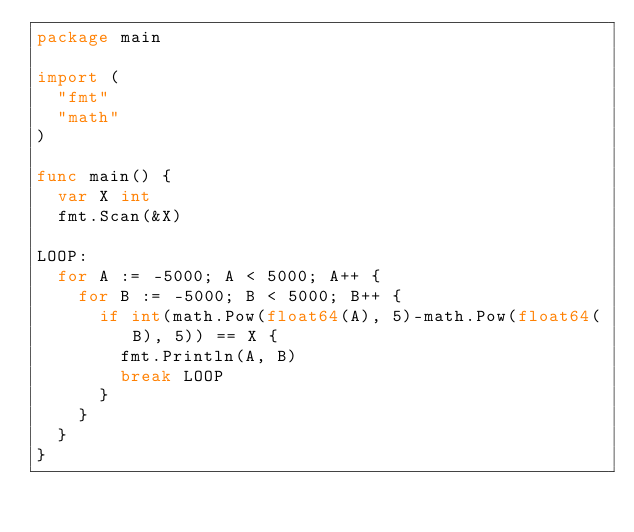<code> <loc_0><loc_0><loc_500><loc_500><_Go_>package main

import (
	"fmt"
	"math"
)

func main() {
	var X int
	fmt.Scan(&X)

LOOP:
	for A := -5000; A < 5000; A++ {
		for B := -5000; B < 5000; B++ {
			if int(math.Pow(float64(A), 5)-math.Pow(float64(B), 5)) == X {
				fmt.Println(A, B)
				break LOOP
			}
		}
	}
}</code> 